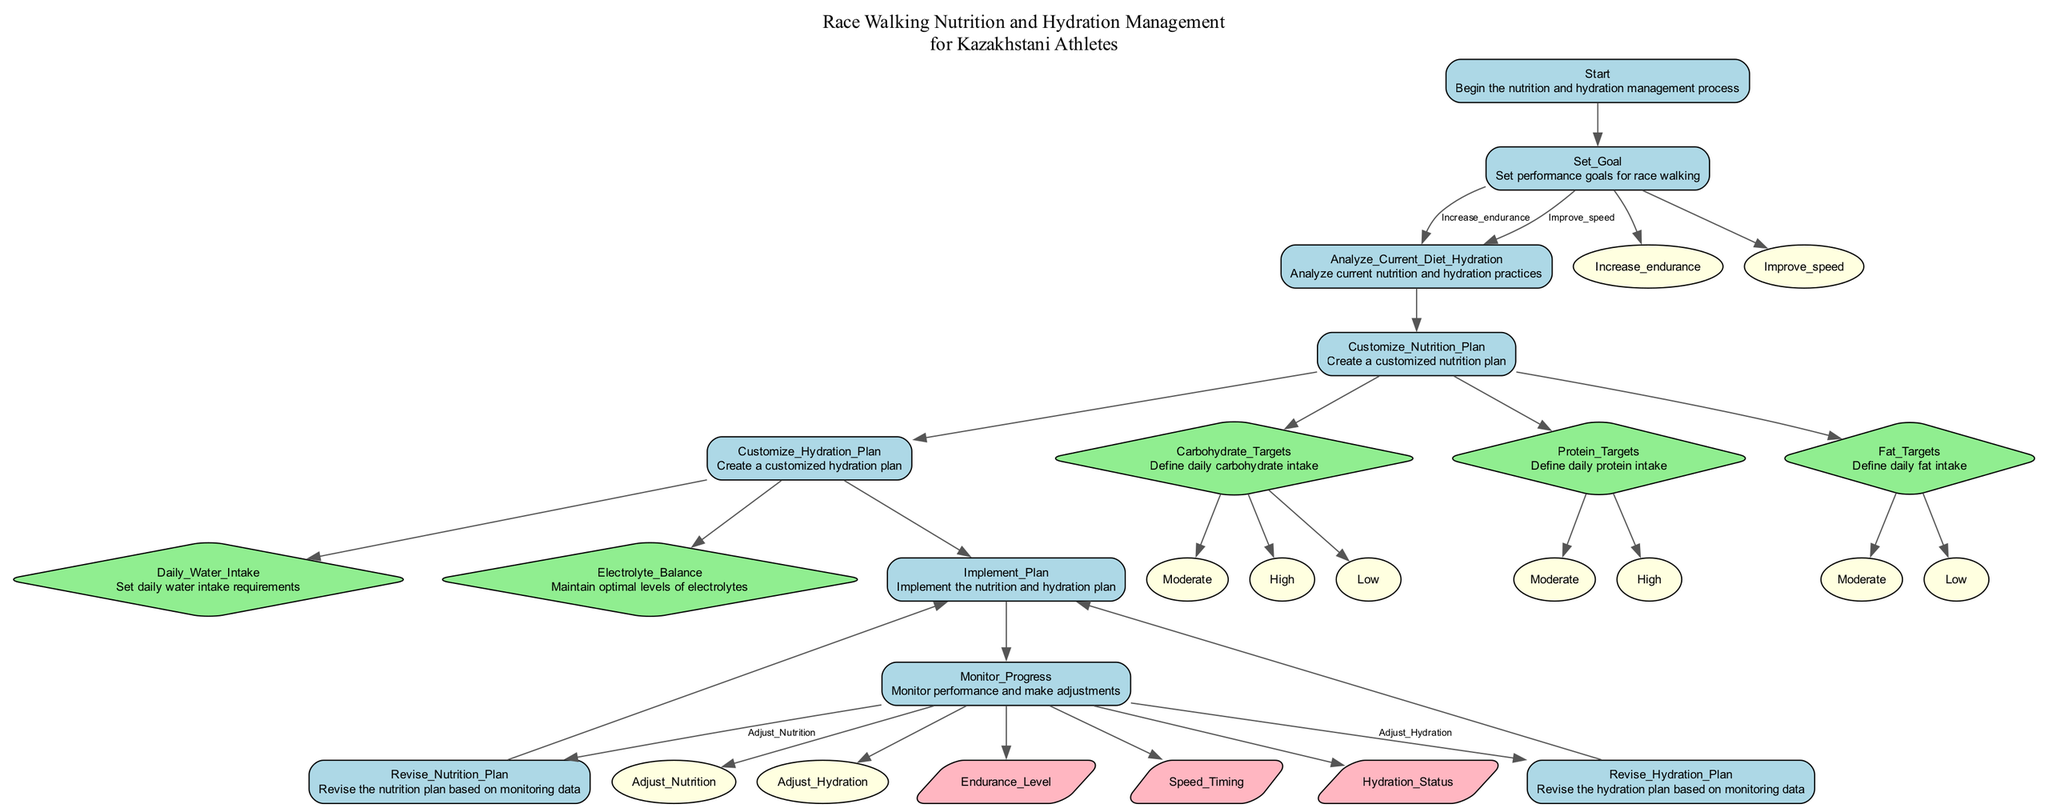What is the first step in managing nutrition and hydration? The first step is labeled "Start" in the diagram, which indicates the initiation of the process related to nutrition and hydration management.
Answer: Start What are the two performance goals that can be set? The diagram lists "Increase endurance" and "Improve speed" as options for performance goals that can be chosen after the initial step.
Answer: Increase endurance, Improve speed How many elements are there in the "Customize Nutrition Plan" node? The "Customize Nutrition Plan" node includes three specific target elements: Carbohydrate Targets, Protein Targets, and Fat Targets, thus totaling three elements.
Answer: 3 What is the next step after analyzing current diet and hydration practices? After analyzing the current diet and hydration practices, the next step indicated in the flowchart is to "Customize Nutrition Plan".
Answer: Customize Nutrition Plan What are the strategies listed for maintaining optimal levels of electrolytes? The diagram specifies two strategies for maintaining optimal electrolyte levels: "Electrolyte Supplements" and "Natural Sources".
Answer: Electrolyte Supplements, Natural Sources What happens if the endurance level needs adjustment? If adjustments are needed based on the endurance level, the flowchart directs to "Adjust Nutrition", which leads to revising the nutrition plan.
Answer: Adjust Nutrition In what context is the "Daily Water Intake" requirement set? The requirement for daily water intake is determined based on the "Climate Condition Kazakhstan" as indicated in the dependency noted in the diagram.
Answer: Climate Condition Kazakhstan How is the "Revise Nutrition Plan" connected to the implementation process? The "Revise Nutrition Plan" node indicates that after revisions based on monitoring data, it leads back to the "Implement Plan" node, which shows the iterative nature of the process.
Answer: Implement Plan What is the last step in the flowchart after monitoring progress? After monitoring progress, the last step indicated is to either "Revise Nutrition Plan" or "Revise Hydration Plan", but both lead back to implementation, thus showing the cycle continues.
Answer: Revise Nutrition Plan, Revise Hydration Plan 